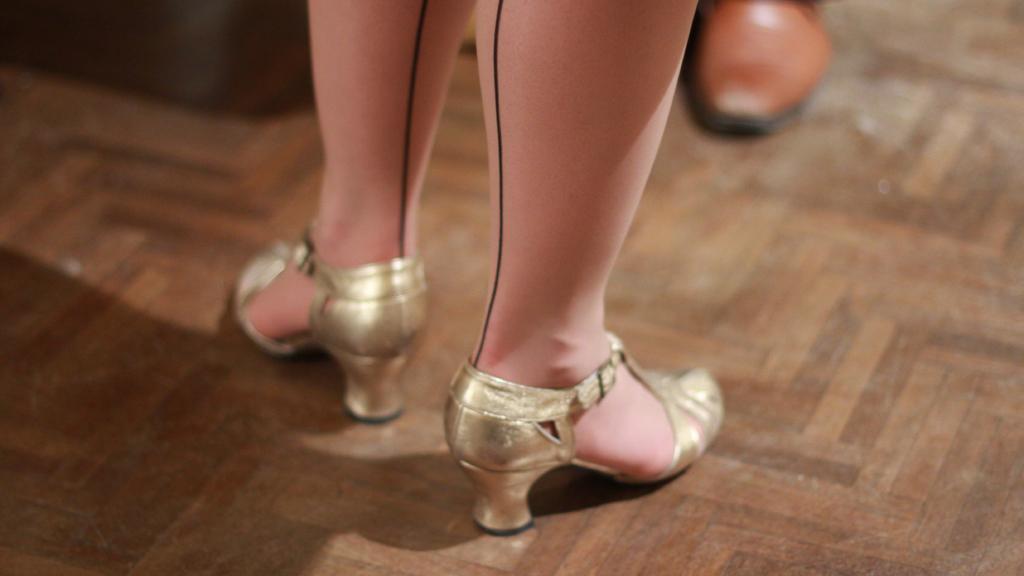Describe this image in one or two sentences. In this image we can see women legs with heels. At the bottom of the image there is floor. In the background of the image there is a person's shoe. 